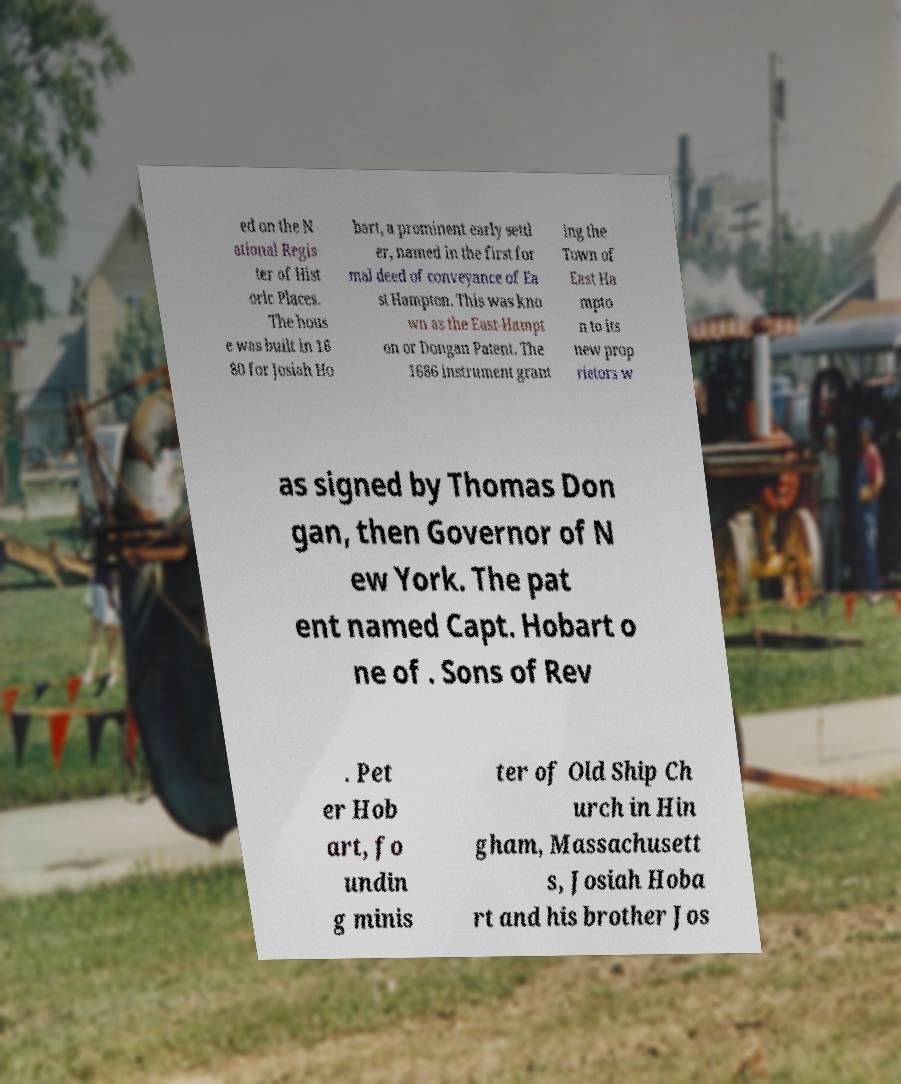There's text embedded in this image that I need extracted. Can you transcribe it verbatim? ed on the N ational Regis ter of Hist oric Places. The hous e was built in 16 80 for Josiah Ho bart, a prominent early settl er, named in the first for mal deed of conveyance of Ea st Hampton. This was kno wn as the East-Hampt on or Dongan Patent. The 1686 instrument grant ing the Town of East Ha mpto n to its new prop rietors w as signed by Thomas Don gan, then Governor of N ew York. The pat ent named Capt. Hobart o ne of . Sons of Rev . Pet er Hob art, fo undin g minis ter of Old Ship Ch urch in Hin gham, Massachusett s, Josiah Hoba rt and his brother Jos 